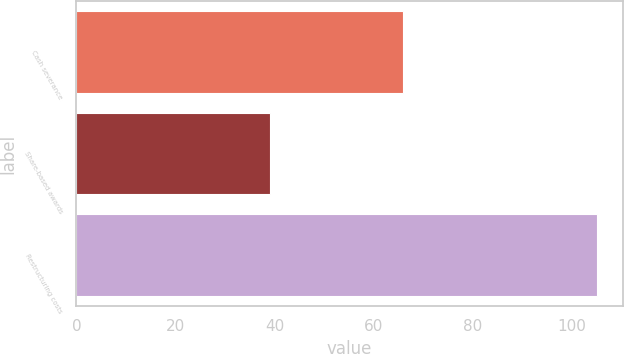Convert chart to OTSL. <chart><loc_0><loc_0><loc_500><loc_500><bar_chart><fcel>Cash severance<fcel>Share-based awards<fcel>Restructuring costs<nl><fcel>66<fcel>39<fcel>105<nl></chart> 